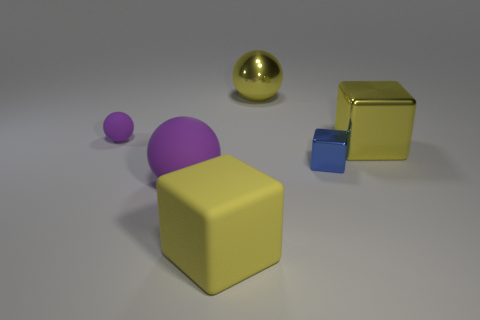Subtract all big shiny spheres. How many spheres are left? 2 Add 2 small objects. How many objects exist? 8 Subtract 1 spheres. How many spheres are left? 2 Add 3 large cubes. How many large cubes are left? 5 Add 2 purple rubber things. How many purple rubber things exist? 4 Subtract all blue cubes. How many cubes are left? 2 Subtract 0 brown spheres. How many objects are left? 6 Subtract all purple cubes. Subtract all cyan cylinders. How many cubes are left? 3 Subtract all yellow blocks. How many yellow spheres are left? 1 Subtract all big spheres. Subtract all large metal things. How many objects are left? 2 